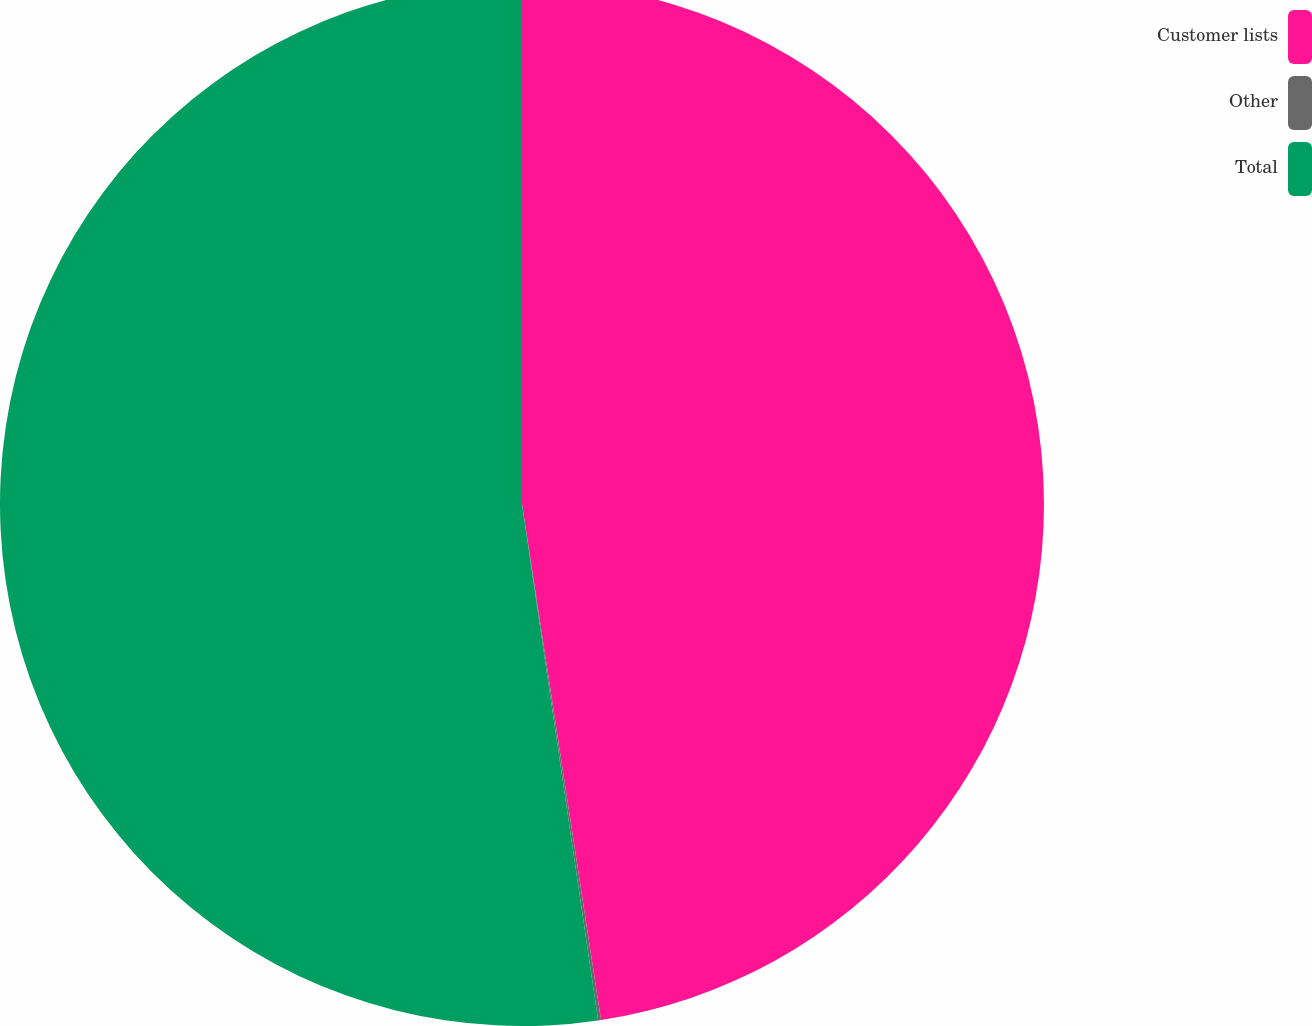<chart> <loc_0><loc_0><loc_500><loc_500><pie_chart><fcel>Customer lists<fcel>Other<fcel>Total<nl><fcel>47.58%<fcel>0.09%<fcel>52.33%<nl></chart> 